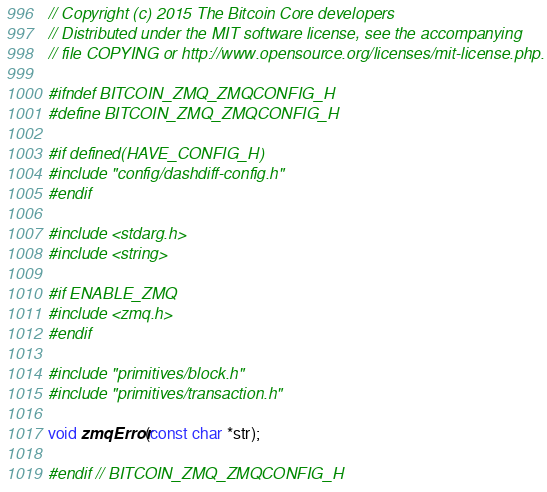Convert code to text. <code><loc_0><loc_0><loc_500><loc_500><_C_>// Copyright (c) 2015 The Bitcoin Core developers
// Distributed under the MIT software license, see the accompanying
// file COPYING or http://www.opensource.org/licenses/mit-license.php.

#ifndef BITCOIN_ZMQ_ZMQCONFIG_H
#define BITCOIN_ZMQ_ZMQCONFIG_H

#if defined(HAVE_CONFIG_H)
#include "config/dashdiff-config.h"
#endif

#include <stdarg.h>
#include <string>

#if ENABLE_ZMQ
#include <zmq.h>
#endif

#include "primitives/block.h"
#include "primitives/transaction.h"

void zmqError(const char *str);

#endif // BITCOIN_ZMQ_ZMQCONFIG_H
</code> 